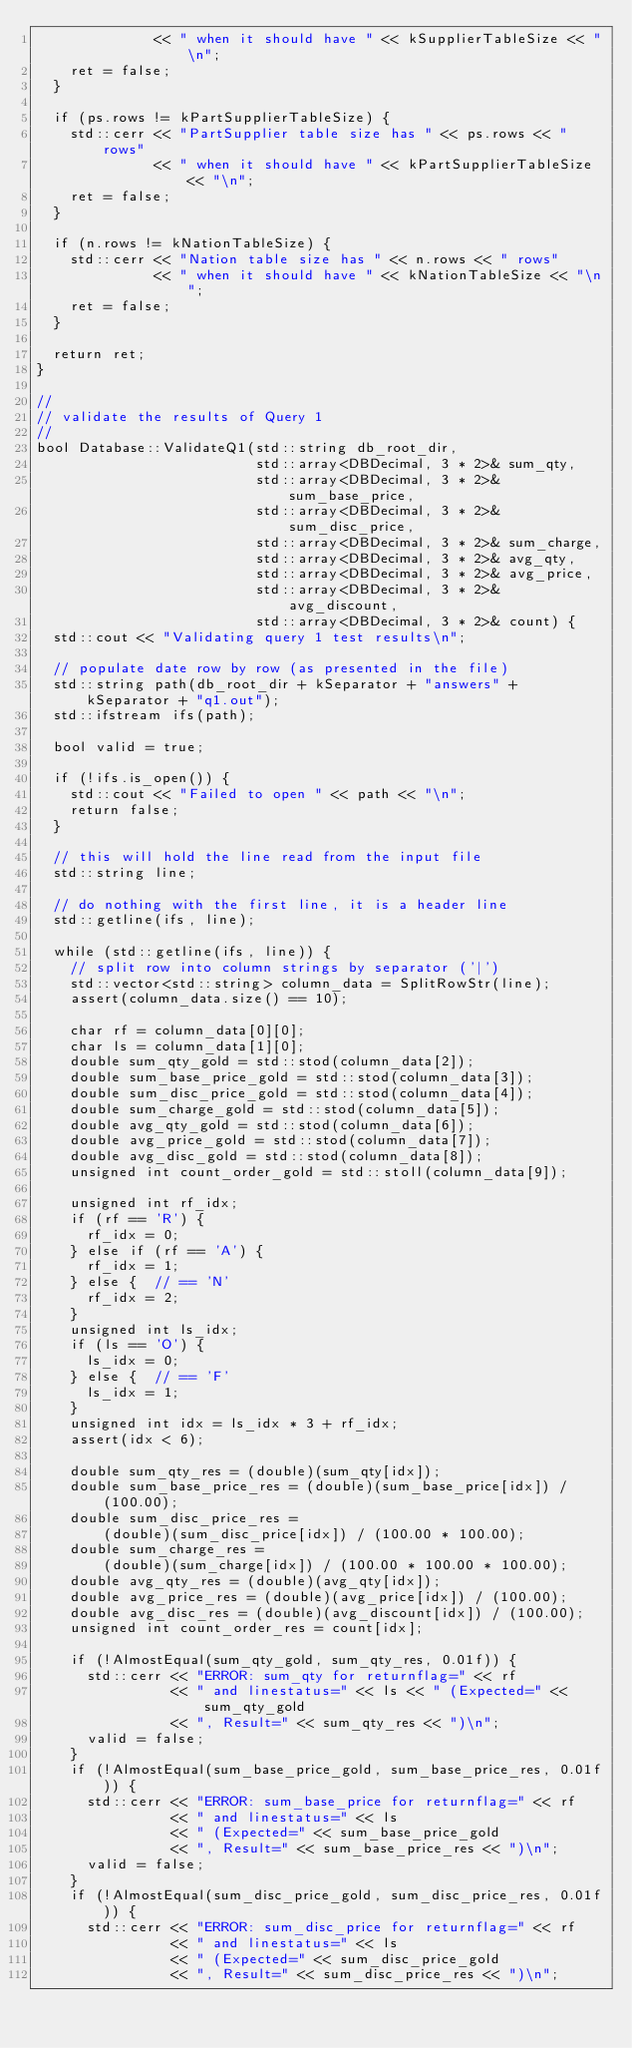<code> <loc_0><loc_0><loc_500><loc_500><_C++_>              << " when it should have " << kSupplierTableSize << "\n";
    ret = false;
  }

  if (ps.rows != kPartSupplierTableSize) {
    std::cerr << "PartSupplier table size has " << ps.rows << " rows"
              << " when it should have " << kPartSupplierTableSize << "\n";
    ret = false;
  }

  if (n.rows != kNationTableSize) {
    std::cerr << "Nation table size has " << n.rows << " rows"
              << " when it should have " << kNationTableSize << "\n";
    ret = false;
  }

  return ret;
}

//
// validate the results of Query 1
//
bool Database::ValidateQ1(std::string db_root_dir,
                          std::array<DBDecimal, 3 * 2>& sum_qty,
                          std::array<DBDecimal, 3 * 2>& sum_base_price,
                          std::array<DBDecimal, 3 * 2>& sum_disc_price,
                          std::array<DBDecimal, 3 * 2>& sum_charge,
                          std::array<DBDecimal, 3 * 2>& avg_qty,
                          std::array<DBDecimal, 3 * 2>& avg_price,
                          std::array<DBDecimal, 3 * 2>& avg_discount,
                          std::array<DBDecimal, 3 * 2>& count) {
  std::cout << "Validating query 1 test results\n";

  // populate date row by row (as presented in the file)
  std::string path(db_root_dir + kSeparator + "answers" + kSeparator + "q1.out");
  std::ifstream ifs(path);

  bool valid = true;

  if (!ifs.is_open()) {
    std::cout << "Failed to open " << path << "\n";
    return false;
  }

  // this will hold the line read from the input file
  std::string line;

  // do nothing with the first line, it is a header line
  std::getline(ifs, line);

  while (std::getline(ifs, line)) {
    // split row into column strings by separator ('|')
    std::vector<std::string> column_data = SplitRowStr(line);
    assert(column_data.size() == 10);

    char rf = column_data[0][0];
    char ls = column_data[1][0];
    double sum_qty_gold = std::stod(column_data[2]);
    double sum_base_price_gold = std::stod(column_data[3]);
    double sum_disc_price_gold = std::stod(column_data[4]);
    double sum_charge_gold = std::stod(column_data[5]);
    double avg_qty_gold = std::stod(column_data[6]);
    double avg_price_gold = std::stod(column_data[7]);
    double avg_disc_gold = std::stod(column_data[8]);
    unsigned int count_order_gold = std::stoll(column_data[9]);

    unsigned int rf_idx;
    if (rf == 'R') {
      rf_idx = 0;
    } else if (rf == 'A') {
      rf_idx = 1;
    } else {  // == 'N'
      rf_idx = 2;
    }
    unsigned int ls_idx;
    if (ls == 'O') {
      ls_idx = 0;
    } else {  // == 'F'
      ls_idx = 1;
    }
    unsigned int idx = ls_idx * 3 + rf_idx;
    assert(idx < 6);

    double sum_qty_res = (double)(sum_qty[idx]);
    double sum_base_price_res = (double)(sum_base_price[idx]) / (100.00);
    double sum_disc_price_res =
        (double)(sum_disc_price[idx]) / (100.00 * 100.00);
    double sum_charge_res =
        (double)(sum_charge[idx]) / (100.00 * 100.00 * 100.00);
    double avg_qty_res = (double)(avg_qty[idx]);
    double avg_price_res = (double)(avg_price[idx]) / (100.00);
    double avg_disc_res = (double)(avg_discount[idx]) / (100.00);
    unsigned int count_order_res = count[idx];

    if (!AlmostEqual(sum_qty_gold, sum_qty_res, 0.01f)) {
      std::cerr << "ERROR: sum_qty for returnflag=" << rf
                << " and linestatus=" << ls << " (Expected=" << sum_qty_gold
                << ", Result=" << sum_qty_res << ")\n";
      valid = false;
    }
    if (!AlmostEqual(sum_base_price_gold, sum_base_price_res, 0.01f)) {
      std::cerr << "ERROR: sum_base_price for returnflag=" << rf
                << " and linestatus=" << ls
                << " (Expected=" << sum_base_price_gold
                << ", Result=" << sum_base_price_res << ")\n";
      valid = false;
    }
    if (!AlmostEqual(sum_disc_price_gold, sum_disc_price_res, 0.01f)) {
      std::cerr << "ERROR: sum_disc_price for returnflag=" << rf
                << " and linestatus=" << ls
                << " (Expected=" << sum_disc_price_gold
                << ", Result=" << sum_disc_price_res << ")\n";</code> 